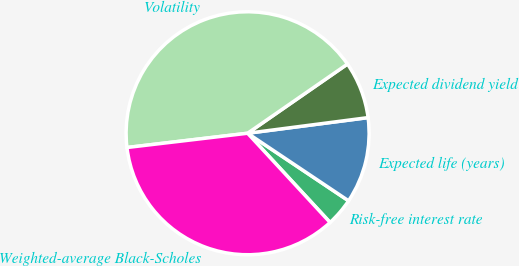<chart> <loc_0><loc_0><loc_500><loc_500><pie_chart><fcel>Risk-free interest rate<fcel>Expected life (years)<fcel>Expected dividend yield<fcel>Volatility<fcel>Weighted-average Black-Scholes<nl><fcel>3.74%<fcel>11.44%<fcel>7.59%<fcel>42.23%<fcel>35.0%<nl></chart> 